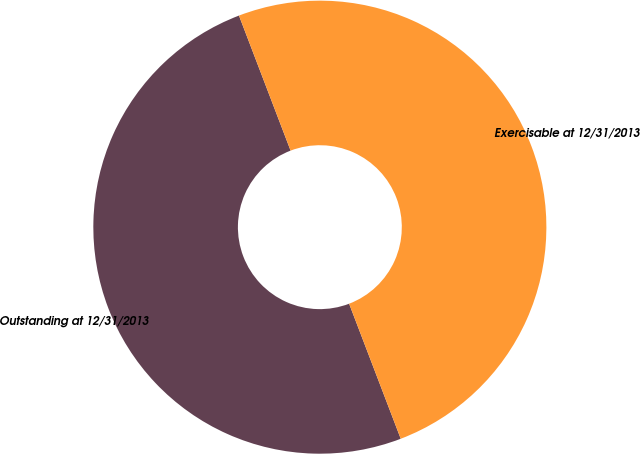Convert chart to OTSL. <chart><loc_0><loc_0><loc_500><loc_500><pie_chart><fcel>Outstanding at 12/31/2013<fcel>Exercisable at 12/31/2013<nl><fcel>50.0%<fcel>50.0%<nl></chart> 